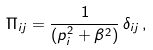<formula> <loc_0><loc_0><loc_500><loc_500>\Pi _ { i j } = \frac { 1 } { ( p _ { i } ^ { 2 } + \beta ^ { 2 } ) } \, \delta _ { i j } \, ,</formula> 